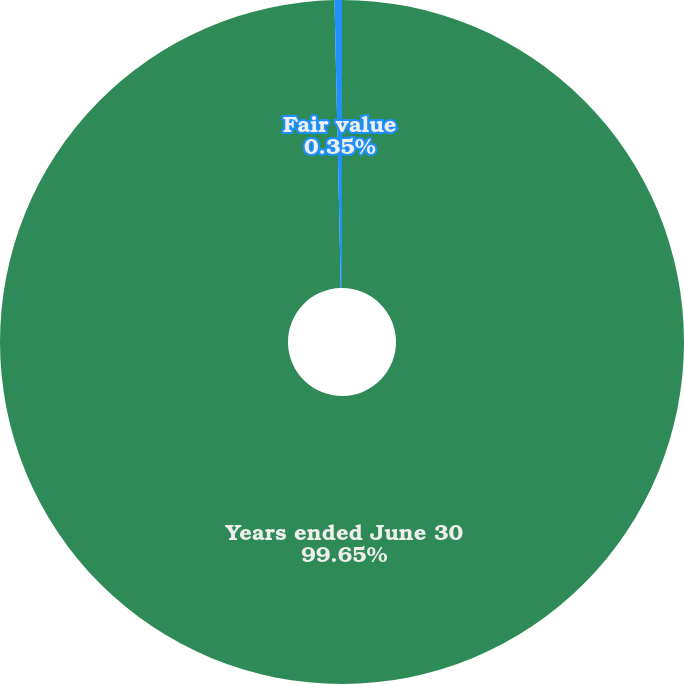Convert chart. <chart><loc_0><loc_0><loc_500><loc_500><pie_chart><fcel>Years ended June 30<fcel>Fair value<nl><fcel>99.65%<fcel>0.35%<nl></chart> 